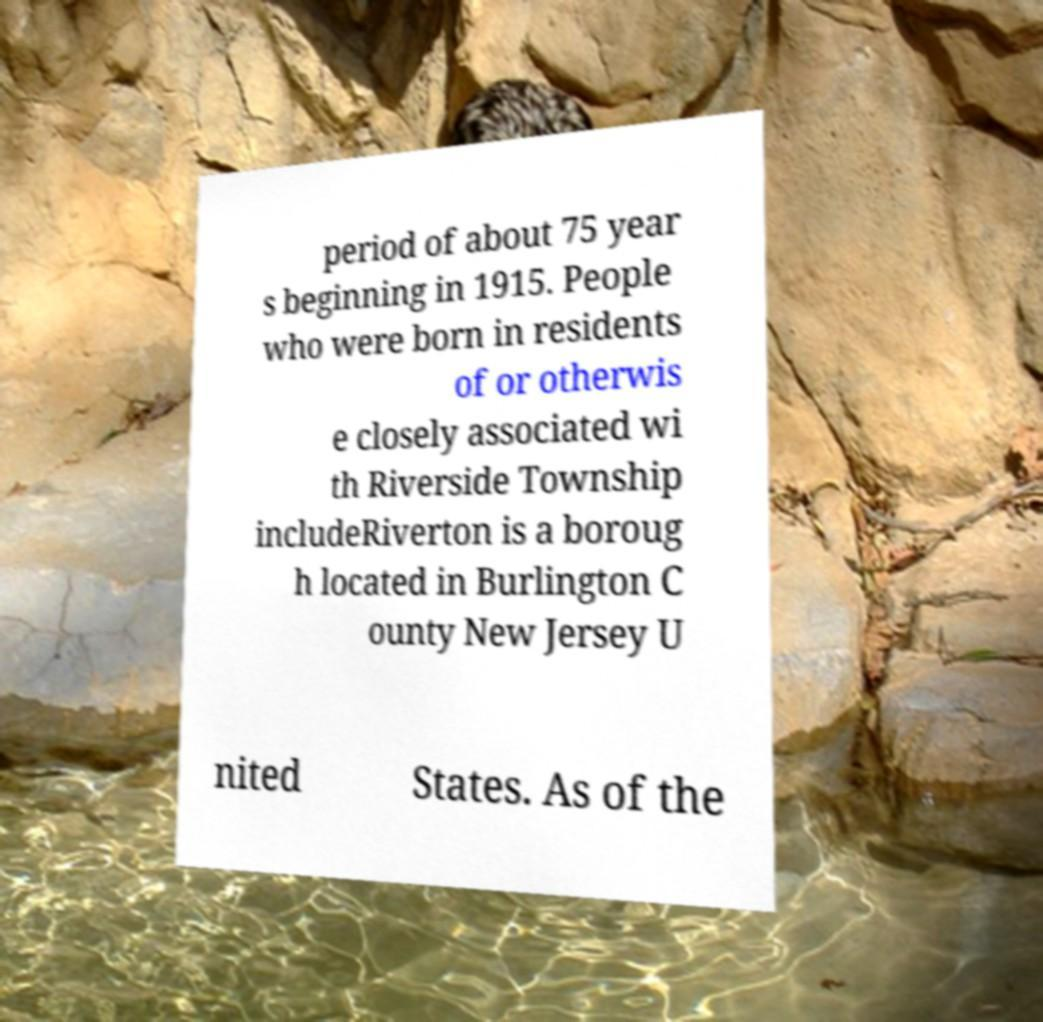What messages or text are displayed in this image? I need them in a readable, typed format. period of about 75 year s beginning in 1915. People who were born in residents of or otherwis e closely associated wi th Riverside Township includeRiverton is a boroug h located in Burlington C ounty New Jersey U nited States. As of the 